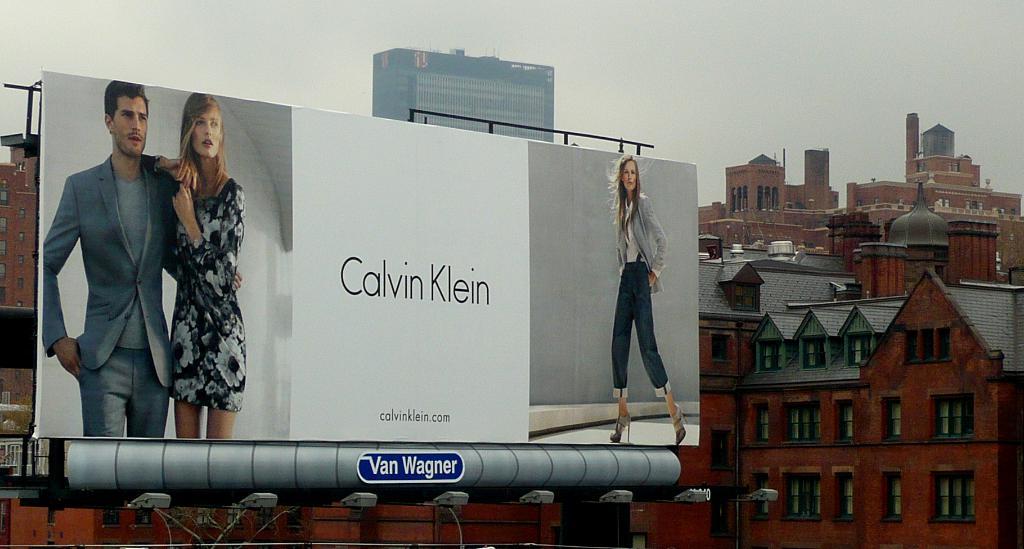What is the name of this brand?
Provide a short and direct response. Calvin klein. 